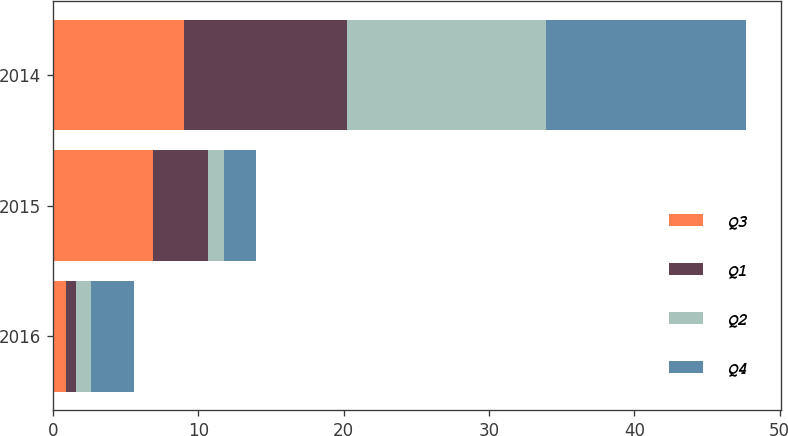Convert chart. <chart><loc_0><loc_0><loc_500><loc_500><stacked_bar_chart><ecel><fcel>2016<fcel>2015<fcel>2014<nl><fcel>Q3<fcel>0.9<fcel>6.9<fcel>9<nl><fcel>Q1<fcel>0.7<fcel>3.8<fcel>11.2<nl><fcel>Q2<fcel>1<fcel>1.1<fcel>13.7<nl><fcel>Q4<fcel>3<fcel>2.2<fcel>13.8<nl></chart> 